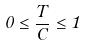Convert formula to latex. <formula><loc_0><loc_0><loc_500><loc_500>0 \leq \frac { T } { C } \leq 1</formula> 